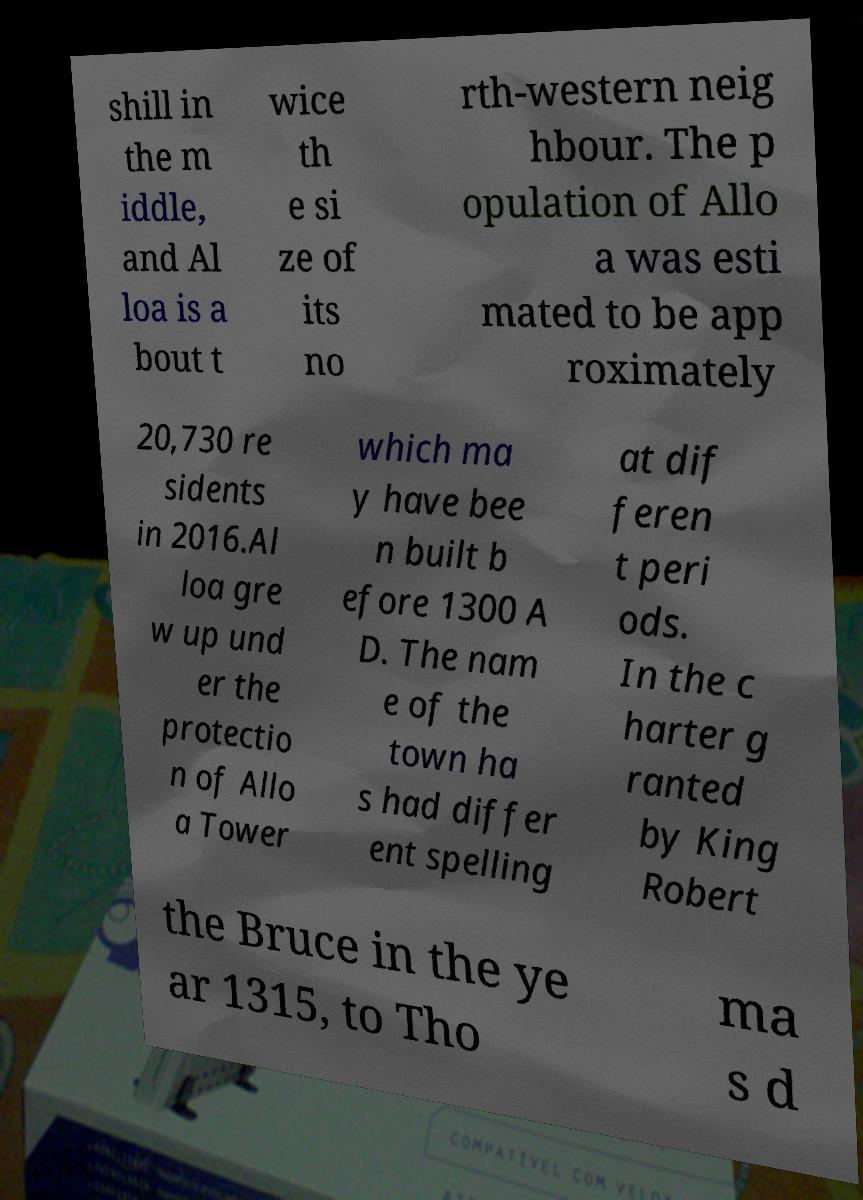Can you accurately transcribe the text from the provided image for me? shill in the m iddle, and Al loa is a bout t wice th e si ze of its no rth-western neig hbour. The p opulation of Allo a was esti mated to be app roximately 20,730 re sidents in 2016.Al loa gre w up und er the protectio n of Allo a Tower which ma y have bee n built b efore 1300 A D. The nam e of the town ha s had differ ent spelling at dif feren t peri ods. In the c harter g ranted by King Robert the Bruce in the ye ar 1315, to Tho ma s d 